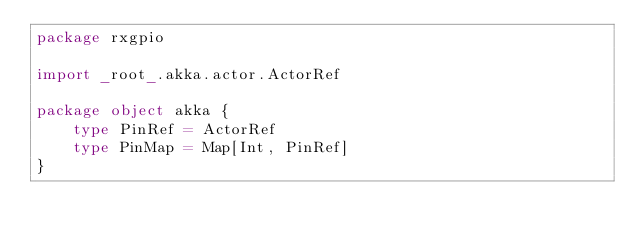Convert code to text. <code><loc_0><loc_0><loc_500><loc_500><_Scala_>package rxgpio

import _root_.akka.actor.ActorRef

package object akka {
    type PinRef = ActorRef
    type PinMap = Map[Int, PinRef]
}
</code> 